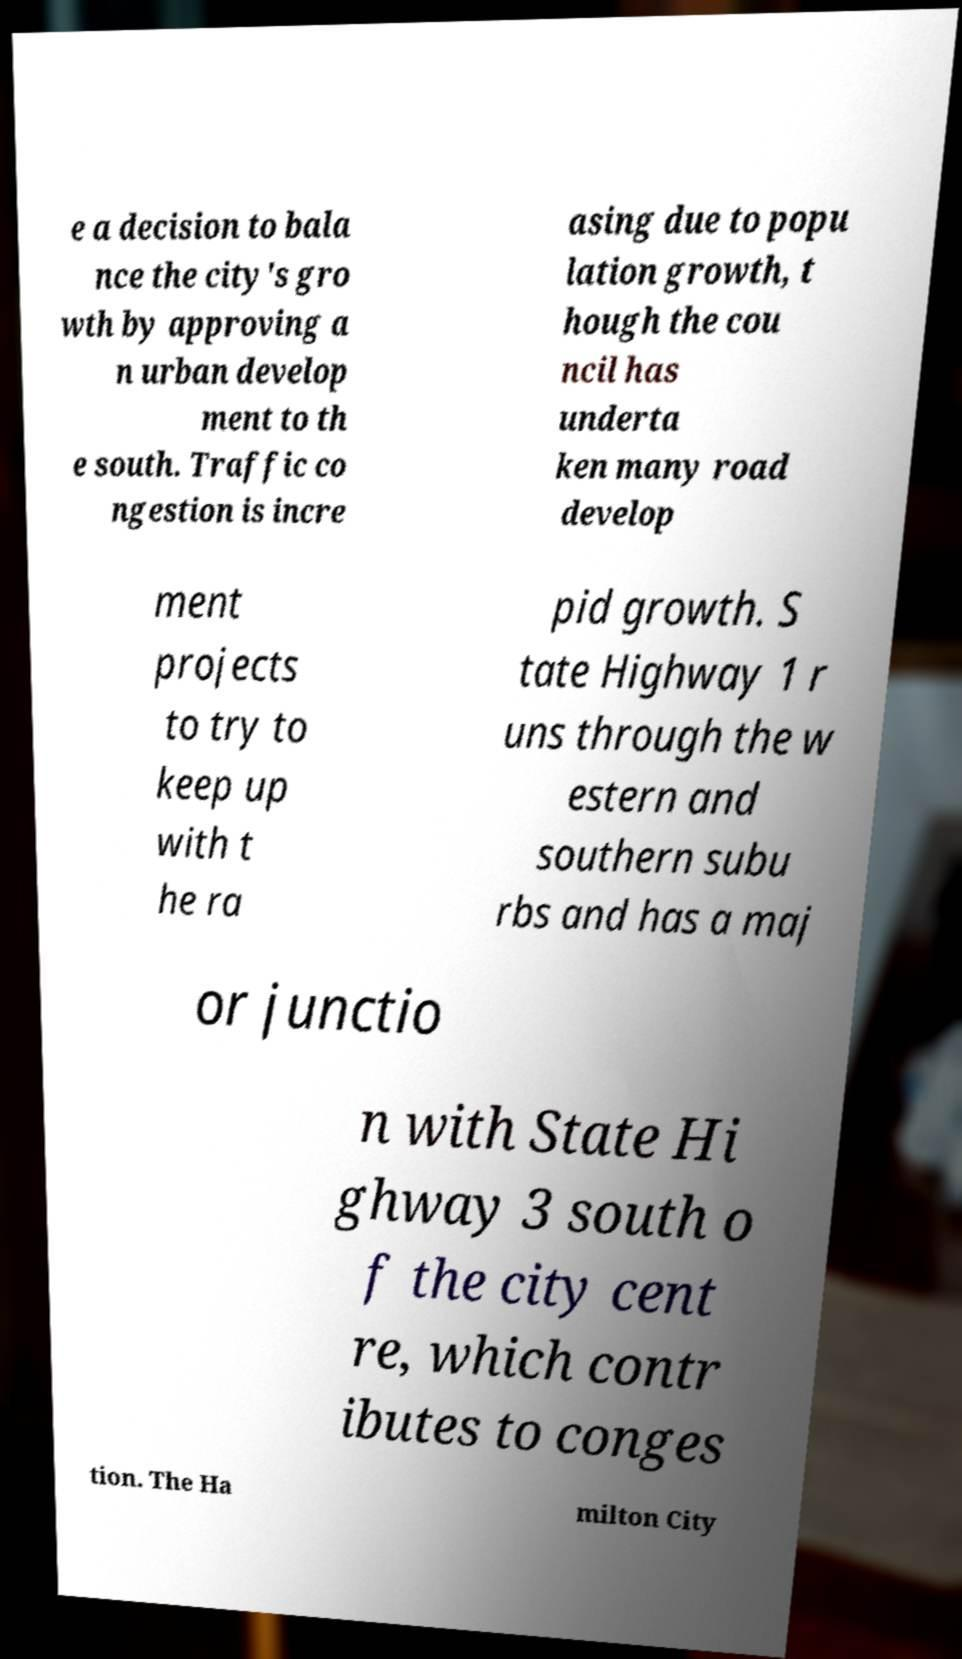Please read and relay the text visible in this image. What does it say? e a decision to bala nce the city's gro wth by approving a n urban develop ment to th e south. Traffic co ngestion is incre asing due to popu lation growth, t hough the cou ncil has underta ken many road develop ment projects to try to keep up with t he ra pid growth. S tate Highway 1 r uns through the w estern and southern subu rbs and has a maj or junctio n with State Hi ghway 3 south o f the city cent re, which contr ibutes to conges tion. The Ha milton City 